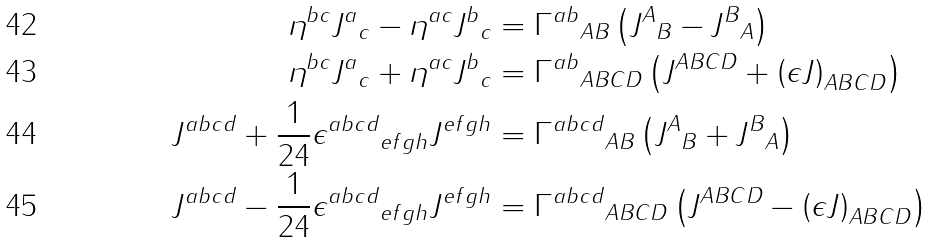<formula> <loc_0><loc_0><loc_500><loc_500>\eta ^ { b c } { J ^ { a } } _ { c } - \eta ^ { a c } { J ^ { b } } _ { c } & = { \Gamma ^ { a b } } _ { A B } \left ( { J ^ { A } } _ { B } - { J ^ { B } } _ { A } \right ) \\ \eta ^ { b c } { J ^ { a } } _ { c } + \eta ^ { a c } { J ^ { b } } _ { c } & = { \Gamma ^ { a b } } _ { A B C D } \left ( J ^ { A B C D } + \left ( \epsilon J \right ) _ { A B C D } \right ) \\ J ^ { a b c d } + \frac { 1 } { 2 4 } { \epsilon ^ { a b c d } } _ { e f g h } J ^ { e f g h } & = { \Gamma ^ { a b c d } } _ { A B } \left ( { J ^ { A } } _ { B } + { J ^ { B } } _ { A } \right ) \\ J ^ { a b c d } - \frac { 1 } { 2 4 } { \epsilon ^ { a b c d } } _ { e f g h } J ^ { e f g h } & = { \Gamma ^ { a b c d } } _ { A B C D } \left ( J ^ { A B C D } - \left ( \epsilon J \right ) _ { A B C D } \right )</formula> 